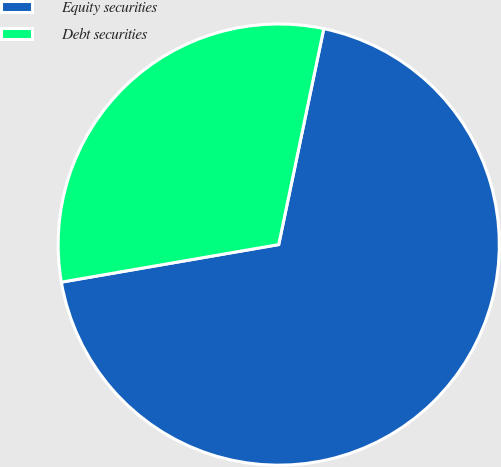Convert chart to OTSL. <chart><loc_0><loc_0><loc_500><loc_500><pie_chart><fcel>Equity securities<fcel>Debt securities<nl><fcel>69.0%<fcel>31.0%<nl></chart> 